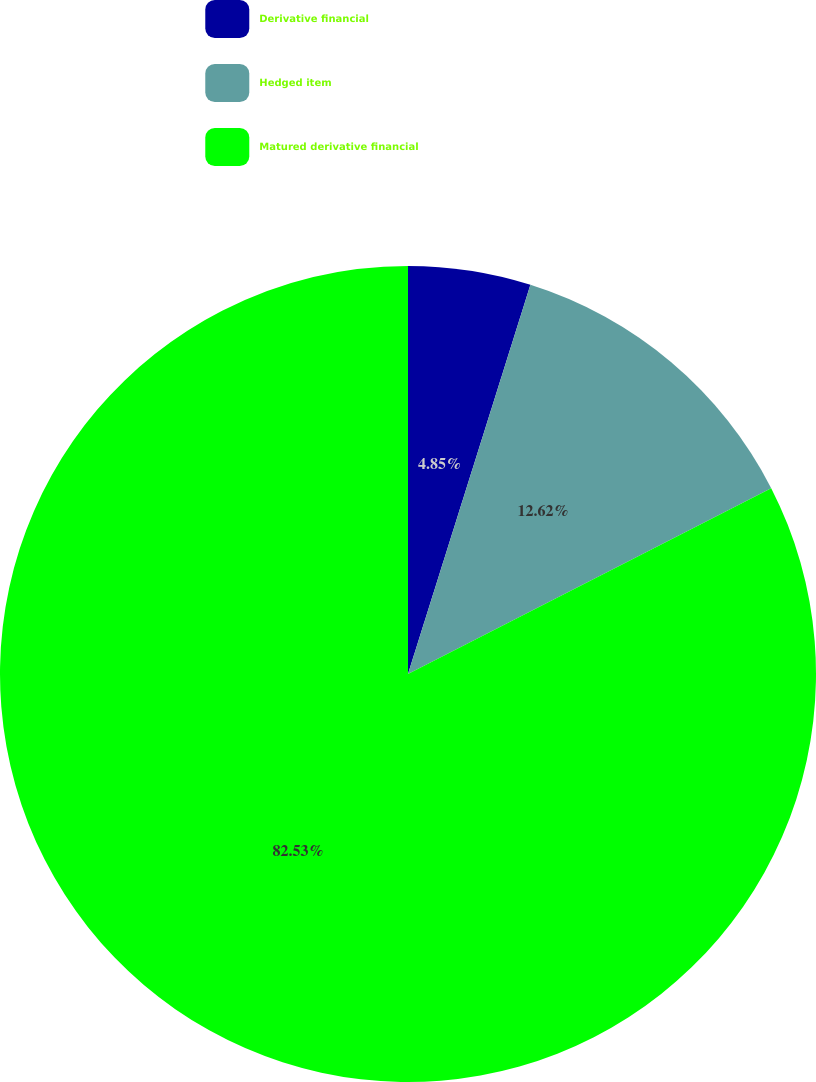Convert chart. <chart><loc_0><loc_0><loc_500><loc_500><pie_chart><fcel>Derivative financial<fcel>Hedged item<fcel>Matured derivative financial<nl><fcel>4.85%<fcel>12.62%<fcel>82.52%<nl></chart> 